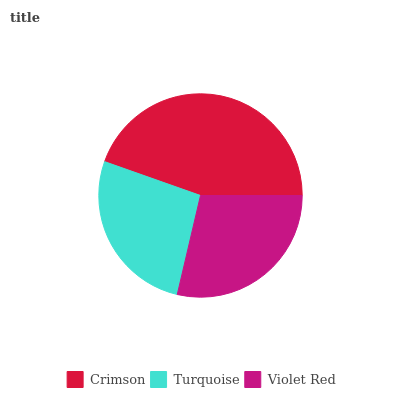Is Turquoise the minimum?
Answer yes or no. Yes. Is Crimson the maximum?
Answer yes or no. Yes. Is Violet Red the minimum?
Answer yes or no. No. Is Violet Red the maximum?
Answer yes or no. No. Is Violet Red greater than Turquoise?
Answer yes or no. Yes. Is Turquoise less than Violet Red?
Answer yes or no. Yes. Is Turquoise greater than Violet Red?
Answer yes or no. No. Is Violet Red less than Turquoise?
Answer yes or no. No. Is Violet Red the high median?
Answer yes or no. Yes. Is Violet Red the low median?
Answer yes or no. Yes. Is Turquoise the high median?
Answer yes or no. No. Is Crimson the low median?
Answer yes or no. No. 